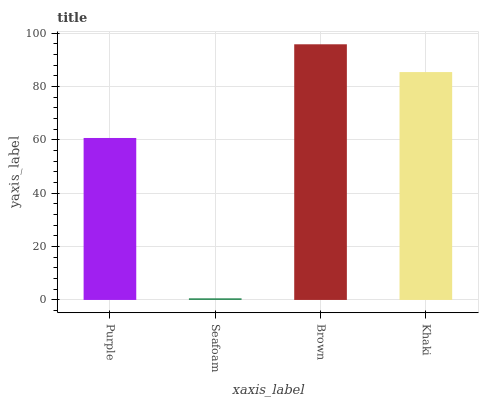Is Seafoam the minimum?
Answer yes or no. Yes. Is Brown the maximum?
Answer yes or no. Yes. Is Brown the minimum?
Answer yes or no. No. Is Seafoam the maximum?
Answer yes or no. No. Is Brown greater than Seafoam?
Answer yes or no. Yes. Is Seafoam less than Brown?
Answer yes or no. Yes. Is Seafoam greater than Brown?
Answer yes or no. No. Is Brown less than Seafoam?
Answer yes or no. No. Is Khaki the high median?
Answer yes or no. Yes. Is Purple the low median?
Answer yes or no. Yes. Is Brown the high median?
Answer yes or no. No. Is Seafoam the low median?
Answer yes or no. No. 